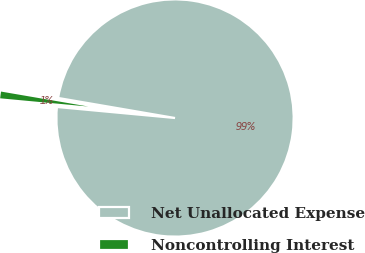Convert chart. <chart><loc_0><loc_0><loc_500><loc_500><pie_chart><fcel>Net Unallocated Expense<fcel>Noncontrolling Interest<nl><fcel>98.78%<fcel>1.22%<nl></chart> 